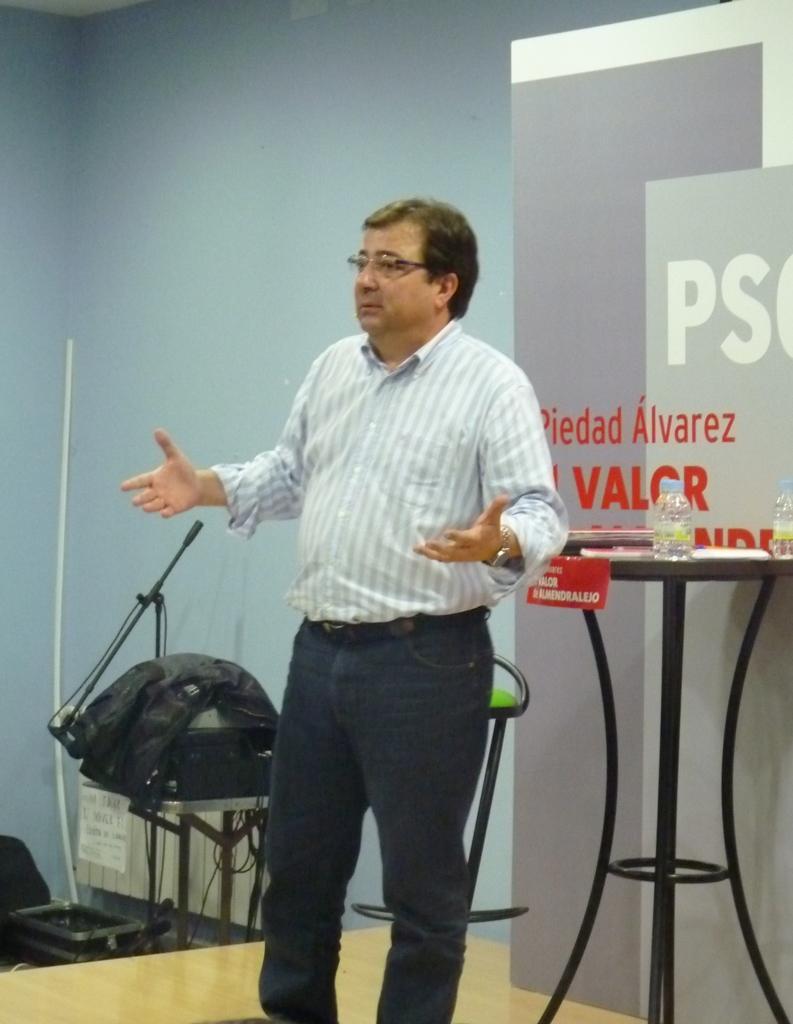In one or two sentences, can you explain what this image depicts? In this image we can see a person standing, behind him there is a stand, on the stand we can see a few water bottles, on the left side, we can see some objects, in the background we can see a poster with some text and wall. 